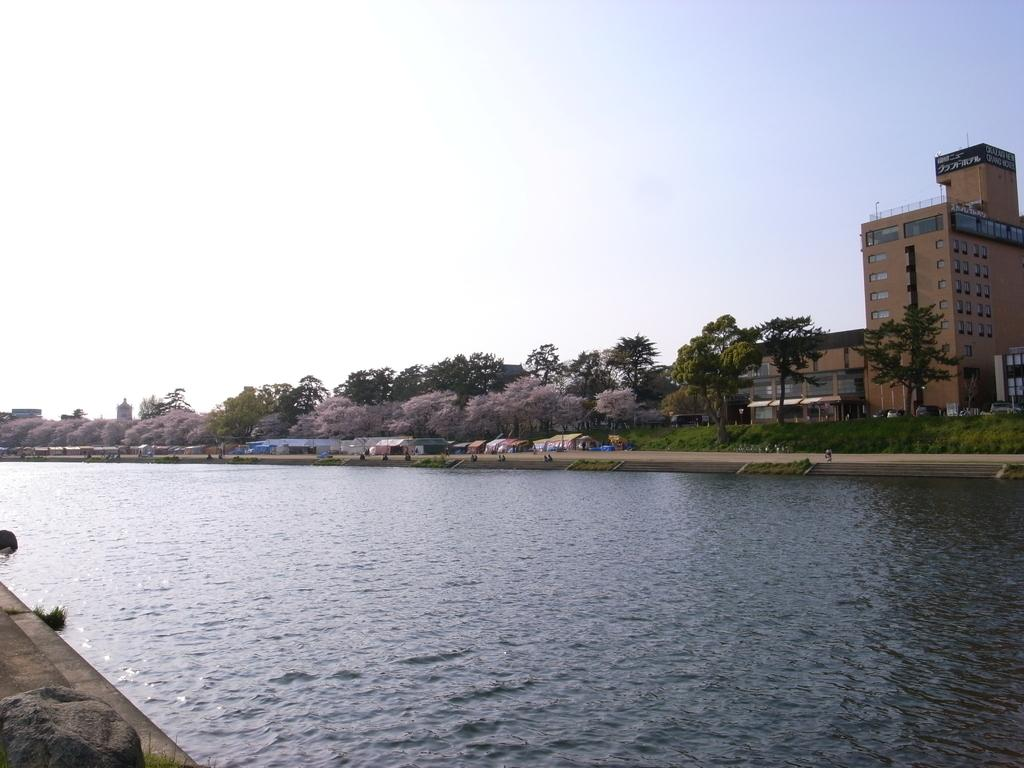What is present in the image that is not solid? There is water visible in the image. What type of structures can be seen in the background of the image? There are buildings in the background of the image. What type of vegetation is present in the background of the image? There are trees with green color in the background of the image. What colors are visible in the sky in the image? The sky is visible in the image, with white and blue colors. Can you see any quivers in the image? There is no mention of quivers in the image, so we cannot say if they are present or not. Are there any flying objects in the image? The image does not show any flying objects; it primarily features water, buildings, trees, and the sky. 